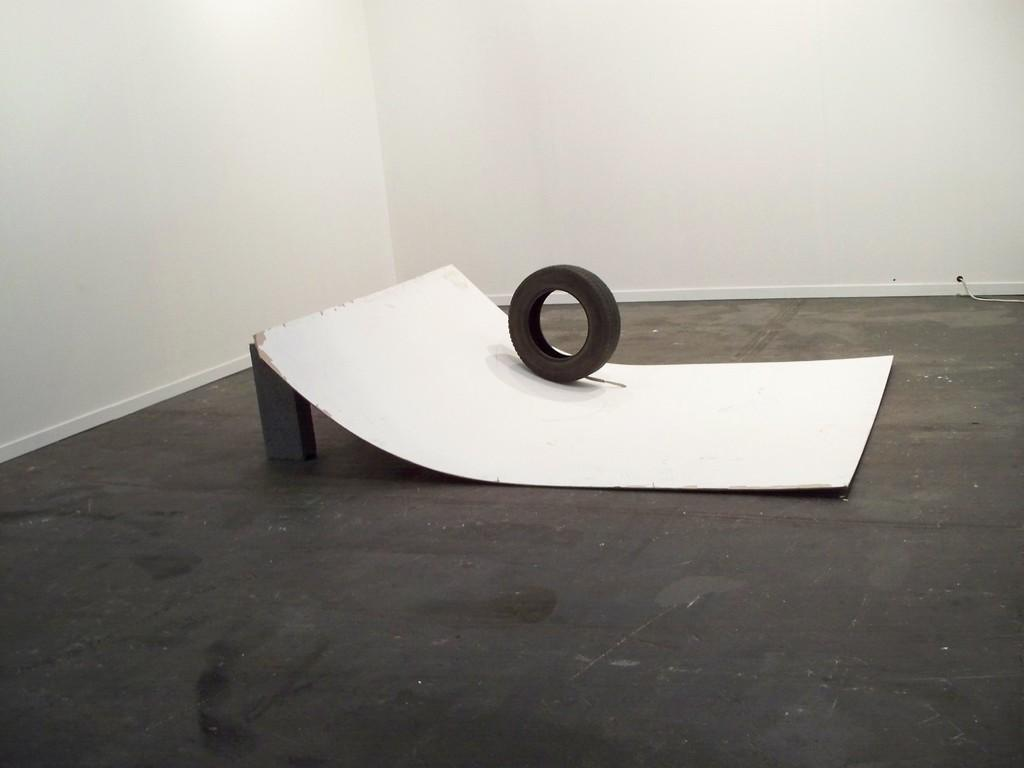What is the main object in the center of the image? There is a board in the center of the image. What is placed on the board? There is a tire on the board. What can be seen behind the board? There is a wall in the background of the image. What surface is visible at the bottom of the image? There is a floor visible at the bottom of the image. What type of guitar can be seen hanging on the wall in the image? There is no guitar present in the image; only a board with a tire and a wall in the background are visible. 